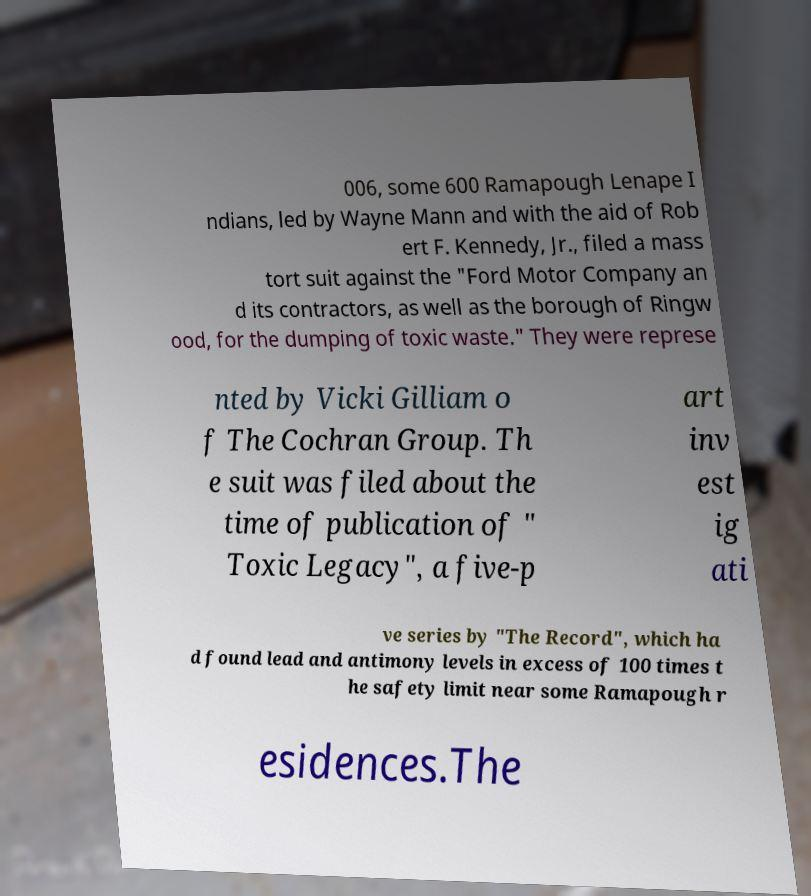Can you accurately transcribe the text from the provided image for me? 006, some 600 Ramapough Lenape I ndians, led by Wayne Mann and with the aid of Rob ert F. Kennedy, Jr., filed a mass tort suit against the "Ford Motor Company an d its contractors, as well as the borough of Ringw ood, for the dumping of toxic waste." They were represe nted by Vicki Gilliam o f The Cochran Group. Th e suit was filed about the time of publication of " Toxic Legacy", a five-p art inv est ig ati ve series by "The Record", which ha d found lead and antimony levels in excess of 100 times t he safety limit near some Ramapough r esidences.The 